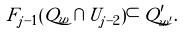Convert formula to latex. <formula><loc_0><loc_0><loc_500><loc_500>F _ { j - 1 } ( Q _ { w } \cap U _ { j - 2 } ) \subset Q ^ { \prime } _ { w ^ { \prime } } .</formula> 